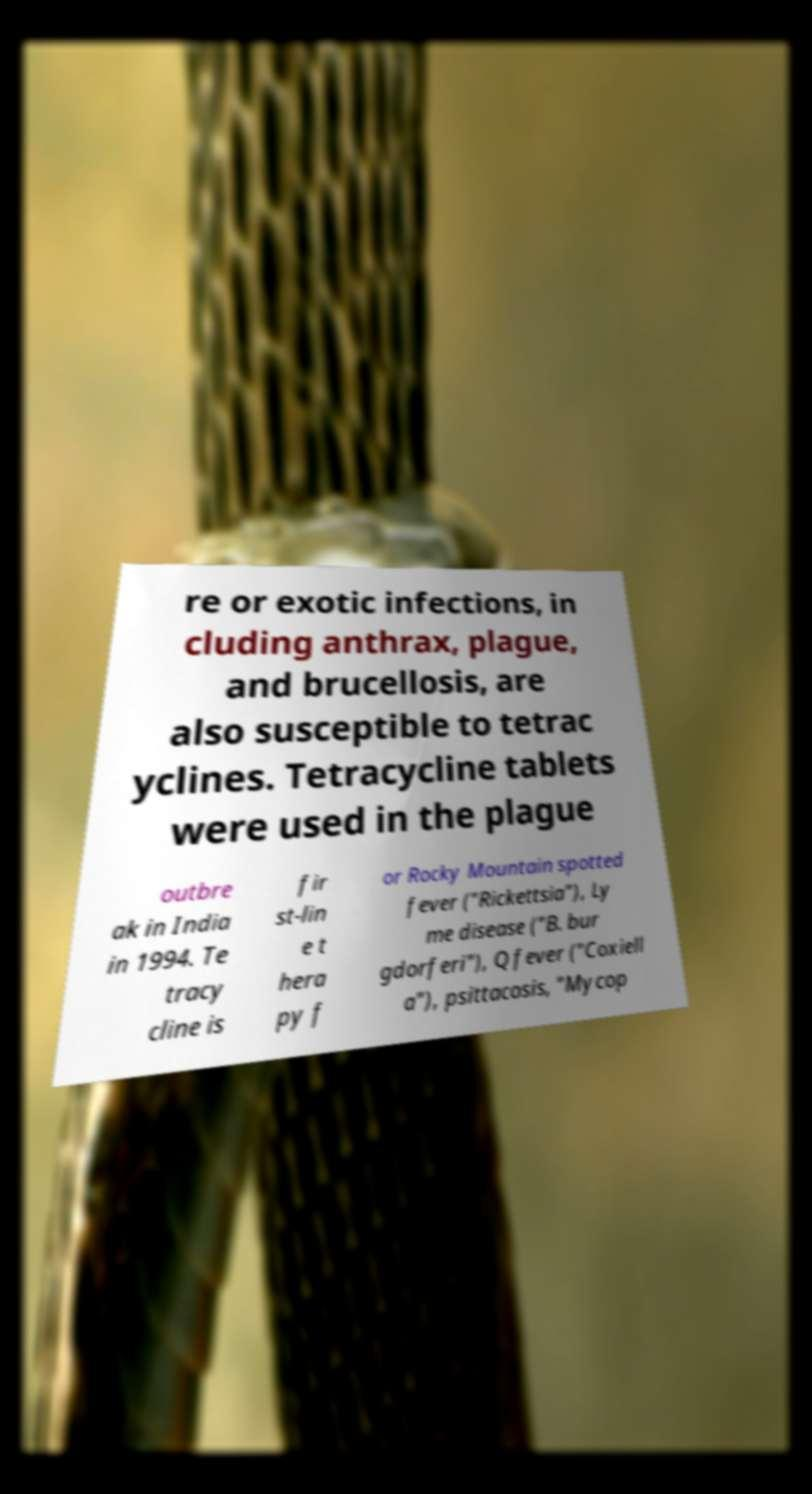Please read and relay the text visible in this image. What does it say? re or exotic infections, in cluding anthrax, plague, and brucellosis, are also susceptible to tetrac yclines. Tetracycline tablets were used in the plague outbre ak in India in 1994. Te tracy cline is fir st-lin e t hera py f or Rocky Mountain spotted fever ("Rickettsia"), Ly me disease ("B. bur gdorferi"), Q fever ("Coxiell a"), psittacosis, "Mycop 